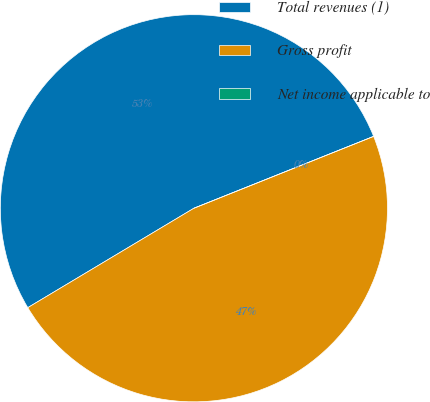Convert chart. <chart><loc_0><loc_0><loc_500><loc_500><pie_chart><fcel>Total revenues (1)<fcel>Gross profit<fcel>Net income applicable to<nl><fcel>52.53%<fcel>47.47%<fcel>0.0%<nl></chart> 